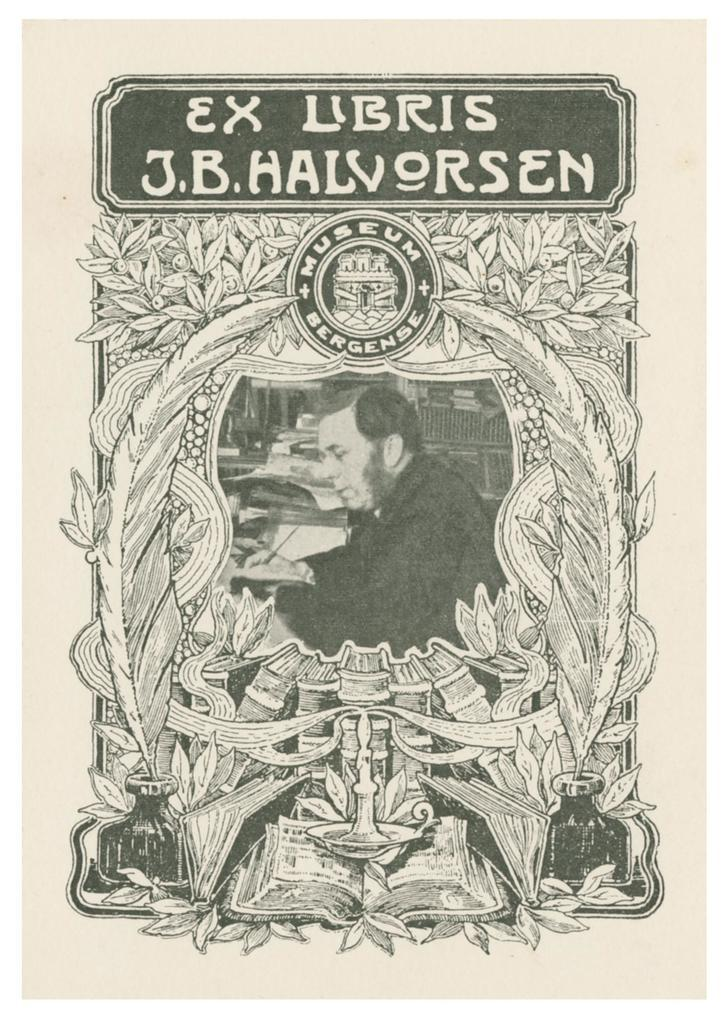<image>
Summarize the visual content of the image. a page that says 'ex libris j.b. halvorsen' on it 